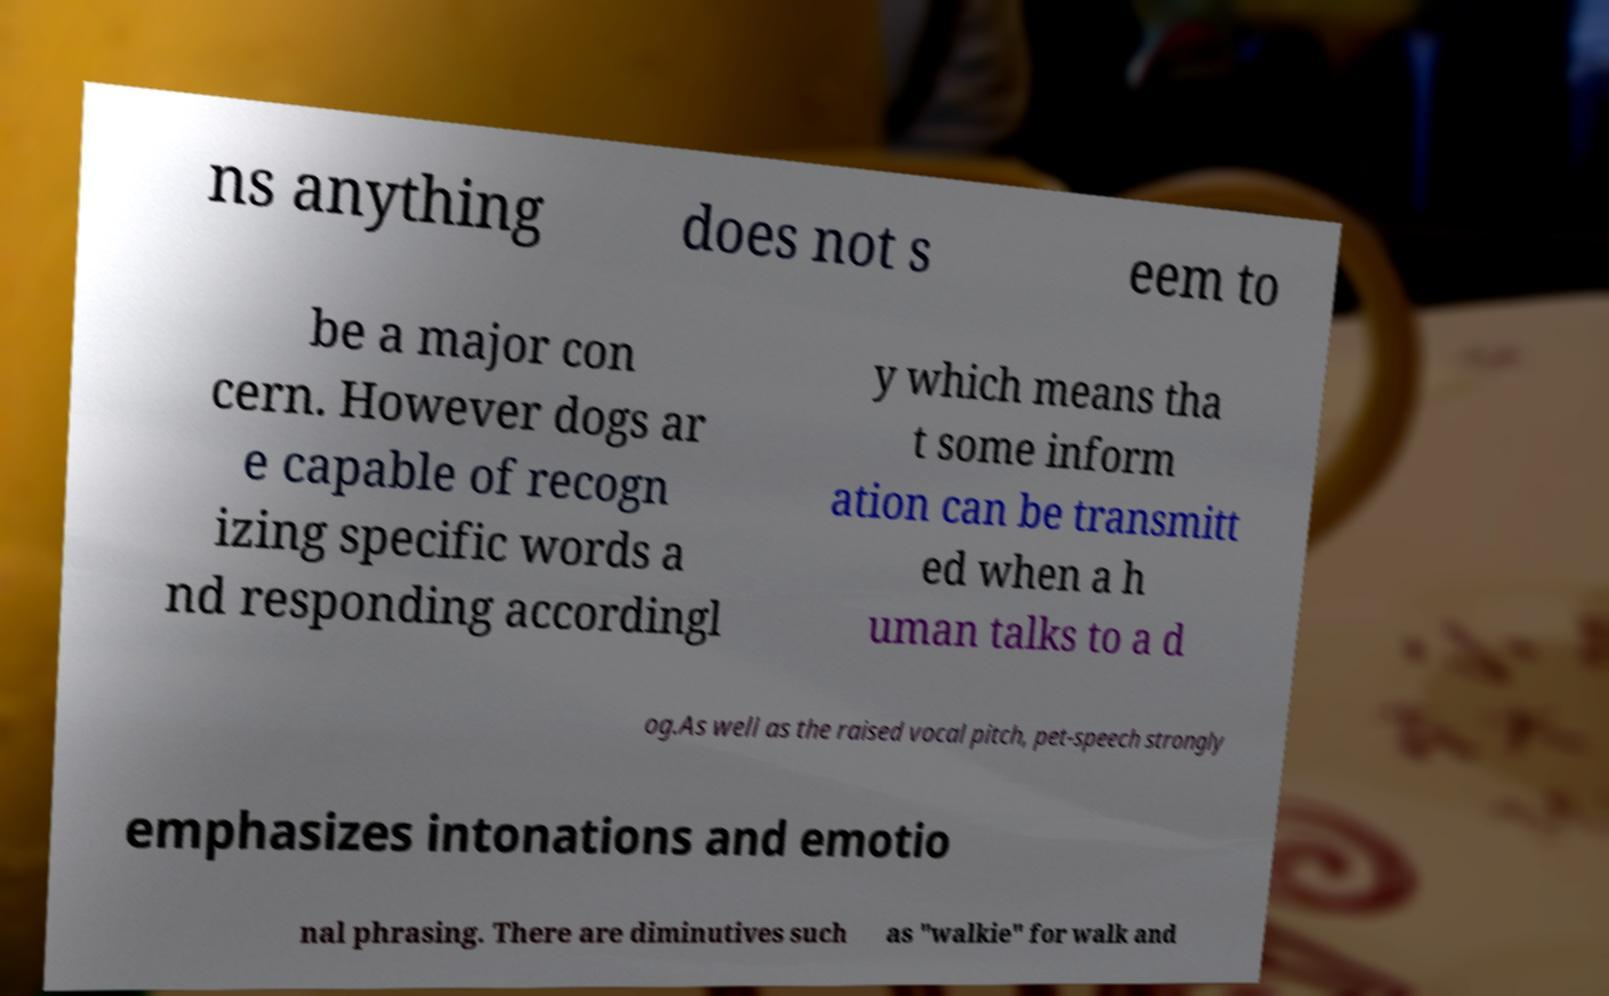Please identify and transcribe the text found in this image. ns anything does not s eem to be a major con cern. However dogs ar e capable of recogn izing specific words a nd responding accordingl y which means tha t some inform ation can be transmitt ed when a h uman talks to a d og.As well as the raised vocal pitch, pet-speech strongly emphasizes intonations and emotio nal phrasing. There are diminutives such as "walkie" for walk and 